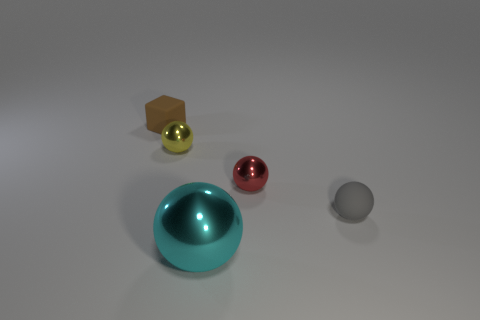Subtract all tiny gray balls. How many balls are left? 3 Subtract all spheres. How many objects are left? 1 Subtract 1 blocks. How many blocks are left? 0 Subtract all red spheres. How many spheres are left? 3 Add 5 matte objects. How many matte objects are left? 7 Add 1 gray objects. How many gray objects exist? 2 Add 5 yellow metal balls. How many objects exist? 10 Subtract 0 blue balls. How many objects are left? 5 Subtract all blue cubes. Subtract all green cylinders. How many cubes are left? 1 Subtract all purple cubes. How many cyan balls are left? 1 